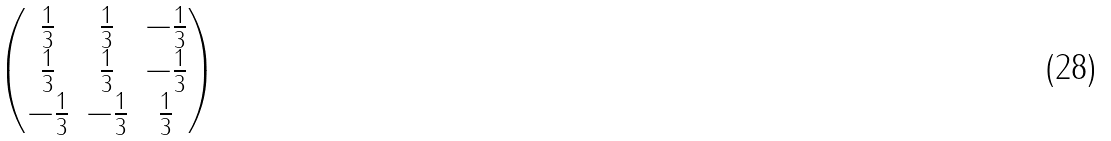<formula> <loc_0><loc_0><loc_500><loc_500>\begin{pmatrix} \frac { 1 } { 3 } & \frac { 1 } { 3 } & - \frac { 1 } { 3 } \\ \frac { 1 } { 3 } & \frac { 1 } { 3 } & - \frac { 1 } { 3 } \\ - \frac { 1 } { 3 } & - \frac { 1 } { 3 } & \frac { 1 } { 3 } \end{pmatrix}</formula> 